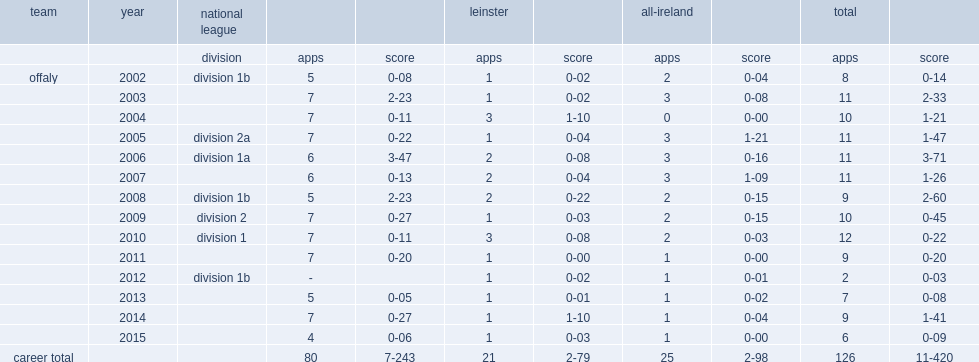Which division did offaly reach in 2009? Division 2. 